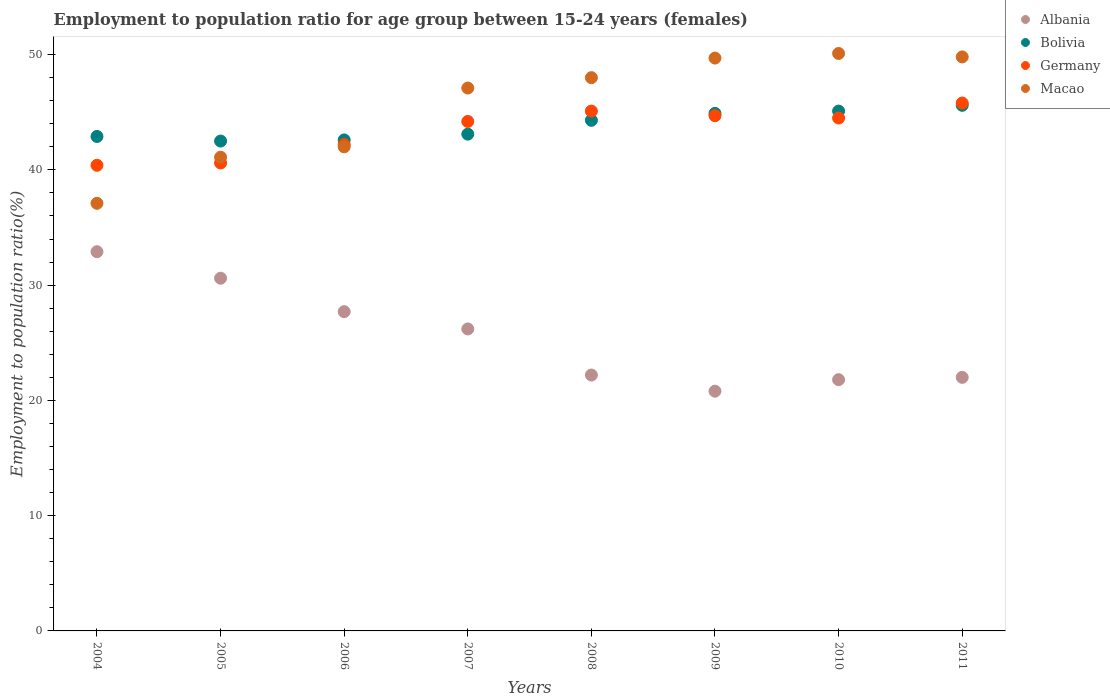How many different coloured dotlines are there?
Your answer should be compact. 4. Is the number of dotlines equal to the number of legend labels?
Provide a succinct answer. Yes. Across all years, what is the maximum employment to population ratio in Bolivia?
Keep it short and to the point. 45.6. Across all years, what is the minimum employment to population ratio in Albania?
Offer a terse response. 20.8. In which year was the employment to population ratio in Albania maximum?
Keep it short and to the point. 2004. In which year was the employment to population ratio in Albania minimum?
Ensure brevity in your answer.  2009. What is the total employment to population ratio in Albania in the graph?
Ensure brevity in your answer.  204.2. What is the difference between the employment to population ratio in Germany in 2004 and that in 2007?
Provide a short and direct response. -3.8. What is the difference between the employment to population ratio in Macao in 2004 and the employment to population ratio in Bolivia in 2009?
Make the answer very short. -7.8. What is the average employment to population ratio in Albania per year?
Provide a short and direct response. 25.53. In the year 2010, what is the difference between the employment to population ratio in Albania and employment to population ratio in Germany?
Ensure brevity in your answer.  -22.7. What is the ratio of the employment to population ratio in Germany in 2005 to that in 2009?
Keep it short and to the point. 0.91. Is the difference between the employment to population ratio in Albania in 2008 and 2010 greater than the difference between the employment to population ratio in Germany in 2008 and 2010?
Provide a short and direct response. No. What is the difference between the highest and the second highest employment to population ratio in Bolivia?
Keep it short and to the point. 0.5. What is the difference between the highest and the lowest employment to population ratio in Bolivia?
Give a very brief answer. 3.1. In how many years, is the employment to population ratio in Macao greater than the average employment to population ratio in Macao taken over all years?
Your response must be concise. 5. Is the sum of the employment to population ratio in Bolivia in 2008 and 2010 greater than the maximum employment to population ratio in Albania across all years?
Give a very brief answer. Yes. Is it the case that in every year, the sum of the employment to population ratio in Macao and employment to population ratio in Albania  is greater than the sum of employment to population ratio in Germany and employment to population ratio in Bolivia?
Ensure brevity in your answer.  No. Does the employment to population ratio in Bolivia monotonically increase over the years?
Give a very brief answer. No. Is the employment to population ratio in Bolivia strictly less than the employment to population ratio in Macao over the years?
Your response must be concise. No. How many dotlines are there?
Your answer should be very brief. 4. Are the values on the major ticks of Y-axis written in scientific E-notation?
Keep it short and to the point. No. Does the graph contain grids?
Ensure brevity in your answer.  No. How many legend labels are there?
Provide a succinct answer. 4. What is the title of the graph?
Keep it short and to the point. Employment to population ratio for age group between 15-24 years (females). Does "Algeria" appear as one of the legend labels in the graph?
Ensure brevity in your answer.  No. What is the label or title of the X-axis?
Give a very brief answer. Years. What is the label or title of the Y-axis?
Offer a terse response. Employment to population ratio(%). What is the Employment to population ratio(%) in Albania in 2004?
Make the answer very short. 32.9. What is the Employment to population ratio(%) in Bolivia in 2004?
Offer a very short reply. 42.9. What is the Employment to population ratio(%) in Germany in 2004?
Keep it short and to the point. 40.4. What is the Employment to population ratio(%) of Macao in 2004?
Offer a very short reply. 37.1. What is the Employment to population ratio(%) in Albania in 2005?
Your response must be concise. 30.6. What is the Employment to population ratio(%) of Bolivia in 2005?
Provide a succinct answer. 42.5. What is the Employment to population ratio(%) in Germany in 2005?
Keep it short and to the point. 40.6. What is the Employment to population ratio(%) in Macao in 2005?
Give a very brief answer. 41.1. What is the Employment to population ratio(%) in Albania in 2006?
Offer a very short reply. 27.7. What is the Employment to population ratio(%) in Bolivia in 2006?
Offer a very short reply. 42.6. What is the Employment to population ratio(%) in Germany in 2006?
Offer a terse response. 42.2. What is the Employment to population ratio(%) in Macao in 2006?
Offer a terse response. 42. What is the Employment to population ratio(%) in Albania in 2007?
Ensure brevity in your answer.  26.2. What is the Employment to population ratio(%) in Bolivia in 2007?
Your answer should be compact. 43.1. What is the Employment to population ratio(%) in Germany in 2007?
Your response must be concise. 44.2. What is the Employment to population ratio(%) of Macao in 2007?
Your answer should be very brief. 47.1. What is the Employment to population ratio(%) of Albania in 2008?
Offer a terse response. 22.2. What is the Employment to population ratio(%) in Bolivia in 2008?
Your answer should be very brief. 44.3. What is the Employment to population ratio(%) of Germany in 2008?
Provide a short and direct response. 45.1. What is the Employment to population ratio(%) in Macao in 2008?
Give a very brief answer. 48. What is the Employment to population ratio(%) in Albania in 2009?
Offer a terse response. 20.8. What is the Employment to population ratio(%) in Bolivia in 2009?
Your answer should be very brief. 44.9. What is the Employment to population ratio(%) in Germany in 2009?
Your response must be concise. 44.7. What is the Employment to population ratio(%) of Macao in 2009?
Provide a succinct answer. 49.7. What is the Employment to population ratio(%) of Albania in 2010?
Your answer should be very brief. 21.8. What is the Employment to population ratio(%) in Bolivia in 2010?
Your response must be concise. 45.1. What is the Employment to population ratio(%) in Germany in 2010?
Provide a short and direct response. 44.5. What is the Employment to population ratio(%) in Macao in 2010?
Give a very brief answer. 50.1. What is the Employment to population ratio(%) in Albania in 2011?
Offer a terse response. 22. What is the Employment to population ratio(%) in Bolivia in 2011?
Offer a terse response. 45.6. What is the Employment to population ratio(%) in Germany in 2011?
Give a very brief answer. 45.8. What is the Employment to population ratio(%) of Macao in 2011?
Your answer should be compact. 49.8. Across all years, what is the maximum Employment to population ratio(%) of Albania?
Make the answer very short. 32.9. Across all years, what is the maximum Employment to population ratio(%) in Bolivia?
Keep it short and to the point. 45.6. Across all years, what is the maximum Employment to population ratio(%) of Germany?
Make the answer very short. 45.8. Across all years, what is the maximum Employment to population ratio(%) in Macao?
Give a very brief answer. 50.1. Across all years, what is the minimum Employment to population ratio(%) in Albania?
Offer a very short reply. 20.8. Across all years, what is the minimum Employment to population ratio(%) in Bolivia?
Offer a terse response. 42.5. Across all years, what is the minimum Employment to population ratio(%) in Germany?
Offer a very short reply. 40.4. Across all years, what is the minimum Employment to population ratio(%) of Macao?
Keep it short and to the point. 37.1. What is the total Employment to population ratio(%) in Albania in the graph?
Provide a succinct answer. 204.2. What is the total Employment to population ratio(%) in Bolivia in the graph?
Your answer should be very brief. 351. What is the total Employment to population ratio(%) in Germany in the graph?
Keep it short and to the point. 347.5. What is the total Employment to population ratio(%) in Macao in the graph?
Your answer should be compact. 364.9. What is the difference between the Employment to population ratio(%) in Macao in 2004 and that in 2005?
Provide a succinct answer. -4. What is the difference between the Employment to population ratio(%) in Albania in 2004 and that in 2006?
Give a very brief answer. 5.2. What is the difference between the Employment to population ratio(%) of Bolivia in 2004 and that in 2006?
Provide a succinct answer. 0.3. What is the difference between the Employment to population ratio(%) in Albania in 2004 and that in 2008?
Offer a terse response. 10.7. What is the difference between the Employment to population ratio(%) in Germany in 2004 and that in 2008?
Make the answer very short. -4.7. What is the difference between the Employment to population ratio(%) of Macao in 2004 and that in 2008?
Your answer should be compact. -10.9. What is the difference between the Employment to population ratio(%) in Albania in 2004 and that in 2010?
Your answer should be compact. 11.1. What is the difference between the Employment to population ratio(%) in Germany in 2004 and that in 2010?
Ensure brevity in your answer.  -4.1. What is the difference between the Employment to population ratio(%) of Macao in 2004 and that in 2010?
Your answer should be very brief. -13. What is the difference between the Employment to population ratio(%) in Albania in 2004 and that in 2011?
Keep it short and to the point. 10.9. What is the difference between the Employment to population ratio(%) in Germany in 2004 and that in 2011?
Offer a very short reply. -5.4. What is the difference between the Employment to population ratio(%) of Macao in 2004 and that in 2011?
Your answer should be very brief. -12.7. What is the difference between the Employment to population ratio(%) in Albania in 2005 and that in 2006?
Your answer should be compact. 2.9. What is the difference between the Employment to population ratio(%) of Bolivia in 2005 and that in 2006?
Your response must be concise. -0.1. What is the difference between the Employment to population ratio(%) in Albania in 2005 and that in 2007?
Offer a very short reply. 4.4. What is the difference between the Employment to population ratio(%) of Germany in 2005 and that in 2007?
Provide a succinct answer. -3.6. What is the difference between the Employment to population ratio(%) of Macao in 2005 and that in 2007?
Offer a terse response. -6. What is the difference between the Employment to population ratio(%) of Albania in 2005 and that in 2008?
Offer a terse response. 8.4. What is the difference between the Employment to population ratio(%) in Macao in 2005 and that in 2008?
Provide a succinct answer. -6.9. What is the difference between the Employment to population ratio(%) in Macao in 2005 and that in 2009?
Give a very brief answer. -8.6. What is the difference between the Employment to population ratio(%) in Albania in 2005 and that in 2010?
Give a very brief answer. 8.8. What is the difference between the Employment to population ratio(%) in Bolivia in 2005 and that in 2010?
Provide a short and direct response. -2.6. What is the difference between the Employment to population ratio(%) of Albania in 2005 and that in 2011?
Offer a terse response. 8.6. What is the difference between the Employment to population ratio(%) of Bolivia in 2005 and that in 2011?
Make the answer very short. -3.1. What is the difference between the Employment to population ratio(%) in Germany in 2005 and that in 2011?
Your answer should be very brief. -5.2. What is the difference between the Employment to population ratio(%) of Macao in 2005 and that in 2011?
Provide a succinct answer. -8.7. What is the difference between the Employment to population ratio(%) in Macao in 2006 and that in 2007?
Your answer should be very brief. -5.1. What is the difference between the Employment to population ratio(%) of Albania in 2006 and that in 2008?
Your answer should be compact. 5.5. What is the difference between the Employment to population ratio(%) of Bolivia in 2006 and that in 2008?
Make the answer very short. -1.7. What is the difference between the Employment to population ratio(%) in Albania in 2006 and that in 2009?
Give a very brief answer. 6.9. What is the difference between the Employment to population ratio(%) of Bolivia in 2006 and that in 2010?
Provide a succinct answer. -2.5. What is the difference between the Employment to population ratio(%) of Germany in 2006 and that in 2010?
Offer a terse response. -2.3. What is the difference between the Employment to population ratio(%) in Albania in 2006 and that in 2011?
Your answer should be compact. 5.7. What is the difference between the Employment to population ratio(%) in Bolivia in 2007 and that in 2008?
Give a very brief answer. -1.2. What is the difference between the Employment to population ratio(%) in Macao in 2007 and that in 2008?
Your answer should be very brief. -0.9. What is the difference between the Employment to population ratio(%) of Bolivia in 2007 and that in 2009?
Ensure brevity in your answer.  -1.8. What is the difference between the Employment to population ratio(%) in Germany in 2007 and that in 2009?
Your response must be concise. -0.5. What is the difference between the Employment to population ratio(%) in Bolivia in 2007 and that in 2010?
Make the answer very short. -2. What is the difference between the Employment to population ratio(%) in Albania in 2007 and that in 2011?
Your answer should be very brief. 4.2. What is the difference between the Employment to population ratio(%) of Bolivia in 2007 and that in 2011?
Provide a succinct answer. -2.5. What is the difference between the Employment to population ratio(%) of Germany in 2007 and that in 2011?
Provide a short and direct response. -1.6. What is the difference between the Employment to population ratio(%) of Macao in 2007 and that in 2011?
Offer a terse response. -2.7. What is the difference between the Employment to population ratio(%) in Bolivia in 2008 and that in 2009?
Provide a succinct answer. -0.6. What is the difference between the Employment to population ratio(%) of Germany in 2008 and that in 2009?
Keep it short and to the point. 0.4. What is the difference between the Employment to population ratio(%) in Albania in 2008 and that in 2010?
Your response must be concise. 0.4. What is the difference between the Employment to population ratio(%) in Bolivia in 2008 and that in 2010?
Ensure brevity in your answer.  -0.8. What is the difference between the Employment to population ratio(%) in Germany in 2008 and that in 2010?
Offer a terse response. 0.6. What is the difference between the Employment to population ratio(%) of Macao in 2008 and that in 2010?
Keep it short and to the point. -2.1. What is the difference between the Employment to population ratio(%) in Bolivia in 2008 and that in 2011?
Offer a terse response. -1.3. What is the difference between the Employment to population ratio(%) of Germany in 2008 and that in 2011?
Keep it short and to the point. -0.7. What is the difference between the Employment to population ratio(%) in Macao in 2008 and that in 2011?
Offer a very short reply. -1.8. What is the difference between the Employment to population ratio(%) in Albania in 2009 and that in 2010?
Your response must be concise. -1. What is the difference between the Employment to population ratio(%) in Germany in 2009 and that in 2011?
Your response must be concise. -1.1. What is the difference between the Employment to population ratio(%) of Macao in 2009 and that in 2011?
Give a very brief answer. -0.1. What is the difference between the Employment to population ratio(%) of Albania in 2010 and that in 2011?
Your answer should be compact. -0.2. What is the difference between the Employment to population ratio(%) of Bolivia in 2010 and that in 2011?
Provide a short and direct response. -0.5. What is the difference between the Employment to population ratio(%) of Germany in 2010 and that in 2011?
Your answer should be very brief. -1.3. What is the difference between the Employment to population ratio(%) in Macao in 2010 and that in 2011?
Ensure brevity in your answer.  0.3. What is the difference between the Employment to population ratio(%) of Albania in 2004 and the Employment to population ratio(%) of Bolivia in 2005?
Give a very brief answer. -9.6. What is the difference between the Employment to population ratio(%) in Bolivia in 2004 and the Employment to population ratio(%) in Germany in 2005?
Offer a very short reply. 2.3. What is the difference between the Employment to population ratio(%) of Germany in 2004 and the Employment to population ratio(%) of Macao in 2005?
Provide a short and direct response. -0.7. What is the difference between the Employment to population ratio(%) in Albania in 2004 and the Employment to population ratio(%) in Germany in 2006?
Your answer should be compact. -9.3. What is the difference between the Employment to population ratio(%) of Germany in 2004 and the Employment to population ratio(%) of Macao in 2006?
Your answer should be compact. -1.6. What is the difference between the Employment to population ratio(%) in Albania in 2004 and the Employment to population ratio(%) in Germany in 2007?
Provide a succinct answer. -11.3. What is the difference between the Employment to population ratio(%) in Albania in 2004 and the Employment to population ratio(%) in Macao in 2007?
Ensure brevity in your answer.  -14.2. What is the difference between the Employment to population ratio(%) of Bolivia in 2004 and the Employment to population ratio(%) of Macao in 2007?
Offer a very short reply. -4.2. What is the difference between the Employment to population ratio(%) of Albania in 2004 and the Employment to population ratio(%) of Bolivia in 2008?
Your answer should be very brief. -11.4. What is the difference between the Employment to population ratio(%) in Albania in 2004 and the Employment to population ratio(%) in Germany in 2008?
Offer a terse response. -12.2. What is the difference between the Employment to population ratio(%) in Albania in 2004 and the Employment to population ratio(%) in Macao in 2008?
Your response must be concise. -15.1. What is the difference between the Employment to population ratio(%) of Bolivia in 2004 and the Employment to population ratio(%) of Macao in 2008?
Make the answer very short. -5.1. What is the difference between the Employment to population ratio(%) in Germany in 2004 and the Employment to population ratio(%) in Macao in 2008?
Give a very brief answer. -7.6. What is the difference between the Employment to population ratio(%) in Albania in 2004 and the Employment to population ratio(%) in Macao in 2009?
Your response must be concise. -16.8. What is the difference between the Employment to population ratio(%) in Albania in 2004 and the Employment to population ratio(%) in Bolivia in 2010?
Your answer should be compact. -12.2. What is the difference between the Employment to population ratio(%) of Albania in 2004 and the Employment to population ratio(%) of Macao in 2010?
Offer a very short reply. -17.2. What is the difference between the Employment to population ratio(%) in Germany in 2004 and the Employment to population ratio(%) in Macao in 2010?
Keep it short and to the point. -9.7. What is the difference between the Employment to population ratio(%) of Albania in 2004 and the Employment to population ratio(%) of Bolivia in 2011?
Give a very brief answer. -12.7. What is the difference between the Employment to population ratio(%) of Albania in 2004 and the Employment to population ratio(%) of Macao in 2011?
Offer a very short reply. -16.9. What is the difference between the Employment to population ratio(%) of Bolivia in 2004 and the Employment to population ratio(%) of Macao in 2011?
Your answer should be compact. -6.9. What is the difference between the Employment to population ratio(%) in Albania in 2005 and the Employment to population ratio(%) in Macao in 2006?
Offer a very short reply. -11.4. What is the difference between the Employment to population ratio(%) in Bolivia in 2005 and the Employment to population ratio(%) in Germany in 2006?
Offer a very short reply. 0.3. What is the difference between the Employment to population ratio(%) of Bolivia in 2005 and the Employment to population ratio(%) of Macao in 2006?
Offer a terse response. 0.5. What is the difference between the Employment to population ratio(%) in Albania in 2005 and the Employment to population ratio(%) in Macao in 2007?
Your answer should be compact. -16.5. What is the difference between the Employment to population ratio(%) of Bolivia in 2005 and the Employment to population ratio(%) of Germany in 2007?
Provide a short and direct response. -1.7. What is the difference between the Employment to population ratio(%) in Bolivia in 2005 and the Employment to population ratio(%) in Macao in 2007?
Provide a succinct answer. -4.6. What is the difference between the Employment to population ratio(%) of Germany in 2005 and the Employment to population ratio(%) of Macao in 2007?
Offer a terse response. -6.5. What is the difference between the Employment to population ratio(%) of Albania in 2005 and the Employment to population ratio(%) of Bolivia in 2008?
Ensure brevity in your answer.  -13.7. What is the difference between the Employment to population ratio(%) of Albania in 2005 and the Employment to population ratio(%) of Macao in 2008?
Keep it short and to the point. -17.4. What is the difference between the Employment to population ratio(%) of Bolivia in 2005 and the Employment to population ratio(%) of Macao in 2008?
Provide a succinct answer. -5.5. What is the difference between the Employment to population ratio(%) in Albania in 2005 and the Employment to population ratio(%) in Bolivia in 2009?
Offer a terse response. -14.3. What is the difference between the Employment to population ratio(%) in Albania in 2005 and the Employment to population ratio(%) in Germany in 2009?
Ensure brevity in your answer.  -14.1. What is the difference between the Employment to population ratio(%) in Albania in 2005 and the Employment to population ratio(%) in Macao in 2009?
Keep it short and to the point. -19.1. What is the difference between the Employment to population ratio(%) of Bolivia in 2005 and the Employment to population ratio(%) of Germany in 2009?
Ensure brevity in your answer.  -2.2. What is the difference between the Employment to population ratio(%) of Bolivia in 2005 and the Employment to population ratio(%) of Macao in 2009?
Provide a succinct answer. -7.2. What is the difference between the Employment to population ratio(%) in Albania in 2005 and the Employment to population ratio(%) in Macao in 2010?
Your response must be concise. -19.5. What is the difference between the Employment to population ratio(%) of Germany in 2005 and the Employment to population ratio(%) of Macao in 2010?
Your answer should be compact. -9.5. What is the difference between the Employment to population ratio(%) in Albania in 2005 and the Employment to population ratio(%) in Bolivia in 2011?
Your answer should be very brief. -15. What is the difference between the Employment to population ratio(%) of Albania in 2005 and the Employment to population ratio(%) of Germany in 2011?
Your response must be concise. -15.2. What is the difference between the Employment to population ratio(%) in Albania in 2005 and the Employment to population ratio(%) in Macao in 2011?
Your answer should be very brief. -19.2. What is the difference between the Employment to population ratio(%) of Bolivia in 2005 and the Employment to population ratio(%) of Macao in 2011?
Provide a succinct answer. -7.3. What is the difference between the Employment to population ratio(%) of Germany in 2005 and the Employment to population ratio(%) of Macao in 2011?
Ensure brevity in your answer.  -9.2. What is the difference between the Employment to population ratio(%) in Albania in 2006 and the Employment to population ratio(%) in Bolivia in 2007?
Ensure brevity in your answer.  -15.4. What is the difference between the Employment to population ratio(%) in Albania in 2006 and the Employment to population ratio(%) in Germany in 2007?
Give a very brief answer. -16.5. What is the difference between the Employment to population ratio(%) of Albania in 2006 and the Employment to population ratio(%) of Macao in 2007?
Provide a succinct answer. -19.4. What is the difference between the Employment to population ratio(%) in Bolivia in 2006 and the Employment to population ratio(%) in Germany in 2007?
Make the answer very short. -1.6. What is the difference between the Employment to population ratio(%) of Bolivia in 2006 and the Employment to population ratio(%) of Macao in 2007?
Your answer should be very brief. -4.5. What is the difference between the Employment to population ratio(%) of Germany in 2006 and the Employment to population ratio(%) of Macao in 2007?
Offer a terse response. -4.9. What is the difference between the Employment to population ratio(%) of Albania in 2006 and the Employment to population ratio(%) of Bolivia in 2008?
Give a very brief answer. -16.6. What is the difference between the Employment to population ratio(%) in Albania in 2006 and the Employment to population ratio(%) in Germany in 2008?
Keep it short and to the point. -17.4. What is the difference between the Employment to population ratio(%) of Albania in 2006 and the Employment to population ratio(%) of Macao in 2008?
Your response must be concise. -20.3. What is the difference between the Employment to population ratio(%) of Bolivia in 2006 and the Employment to population ratio(%) of Germany in 2008?
Your response must be concise. -2.5. What is the difference between the Employment to population ratio(%) in Albania in 2006 and the Employment to population ratio(%) in Bolivia in 2009?
Your response must be concise. -17.2. What is the difference between the Employment to population ratio(%) of Albania in 2006 and the Employment to population ratio(%) of Germany in 2009?
Offer a very short reply. -17. What is the difference between the Employment to population ratio(%) of Bolivia in 2006 and the Employment to population ratio(%) of Macao in 2009?
Your response must be concise. -7.1. What is the difference between the Employment to population ratio(%) of Germany in 2006 and the Employment to population ratio(%) of Macao in 2009?
Offer a terse response. -7.5. What is the difference between the Employment to population ratio(%) in Albania in 2006 and the Employment to population ratio(%) in Bolivia in 2010?
Your answer should be compact. -17.4. What is the difference between the Employment to population ratio(%) in Albania in 2006 and the Employment to population ratio(%) in Germany in 2010?
Give a very brief answer. -16.8. What is the difference between the Employment to population ratio(%) in Albania in 2006 and the Employment to population ratio(%) in Macao in 2010?
Provide a short and direct response. -22.4. What is the difference between the Employment to population ratio(%) in Bolivia in 2006 and the Employment to population ratio(%) in Macao in 2010?
Your response must be concise. -7.5. What is the difference between the Employment to population ratio(%) of Germany in 2006 and the Employment to population ratio(%) of Macao in 2010?
Your answer should be very brief. -7.9. What is the difference between the Employment to population ratio(%) of Albania in 2006 and the Employment to population ratio(%) of Bolivia in 2011?
Keep it short and to the point. -17.9. What is the difference between the Employment to population ratio(%) of Albania in 2006 and the Employment to population ratio(%) of Germany in 2011?
Ensure brevity in your answer.  -18.1. What is the difference between the Employment to population ratio(%) of Albania in 2006 and the Employment to population ratio(%) of Macao in 2011?
Give a very brief answer. -22.1. What is the difference between the Employment to population ratio(%) of Bolivia in 2006 and the Employment to population ratio(%) of Macao in 2011?
Your answer should be very brief. -7.2. What is the difference between the Employment to population ratio(%) of Albania in 2007 and the Employment to population ratio(%) of Bolivia in 2008?
Offer a terse response. -18.1. What is the difference between the Employment to population ratio(%) of Albania in 2007 and the Employment to population ratio(%) of Germany in 2008?
Provide a succinct answer. -18.9. What is the difference between the Employment to population ratio(%) of Albania in 2007 and the Employment to population ratio(%) of Macao in 2008?
Your answer should be compact. -21.8. What is the difference between the Employment to population ratio(%) of Germany in 2007 and the Employment to population ratio(%) of Macao in 2008?
Make the answer very short. -3.8. What is the difference between the Employment to population ratio(%) of Albania in 2007 and the Employment to population ratio(%) of Bolivia in 2009?
Your answer should be very brief. -18.7. What is the difference between the Employment to population ratio(%) in Albania in 2007 and the Employment to population ratio(%) in Germany in 2009?
Offer a very short reply. -18.5. What is the difference between the Employment to population ratio(%) of Albania in 2007 and the Employment to population ratio(%) of Macao in 2009?
Keep it short and to the point. -23.5. What is the difference between the Employment to population ratio(%) in Bolivia in 2007 and the Employment to population ratio(%) in Germany in 2009?
Make the answer very short. -1.6. What is the difference between the Employment to population ratio(%) of Bolivia in 2007 and the Employment to population ratio(%) of Macao in 2009?
Your answer should be compact. -6.6. What is the difference between the Employment to population ratio(%) in Germany in 2007 and the Employment to population ratio(%) in Macao in 2009?
Ensure brevity in your answer.  -5.5. What is the difference between the Employment to population ratio(%) in Albania in 2007 and the Employment to population ratio(%) in Bolivia in 2010?
Provide a short and direct response. -18.9. What is the difference between the Employment to population ratio(%) in Albania in 2007 and the Employment to population ratio(%) in Germany in 2010?
Offer a terse response. -18.3. What is the difference between the Employment to population ratio(%) in Albania in 2007 and the Employment to population ratio(%) in Macao in 2010?
Offer a terse response. -23.9. What is the difference between the Employment to population ratio(%) of Bolivia in 2007 and the Employment to population ratio(%) of Macao in 2010?
Give a very brief answer. -7. What is the difference between the Employment to population ratio(%) in Germany in 2007 and the Employment to population ratio(%) in Macao in 2010?
Your answer should be very brief. -5.9. What is the difference between the Employment to population ratio(%) in Albania in 2007 and the Employment to population ratio(%) in Bolivia in 2011?
Give a very brief answer. -19.4. What is the difference between the Employment to population ratio(%) of Albania in 2007 and the Employment to population ratio(%) of Germany in 2011?
Your answer should be very brief. -19.6. What is the difference between the Employment to population ratio(%) of Albania in 2007 and the Employment to population ratio(%) of Macao in 2011?
Ensure brevity in your answer.  -23.6. What is the difference between the Employment to population ratio(%) in Bolivia in 2007 and the Employment to population ratio(%) in Macao in 2011?
Make the answer very short. -6.7. What is the difference between the Employment to population ratio(%) of Albania in 2008 and the Employment to population ratio(%) of Bolivia in 2009?
Offer a very short reply. -22.7. What is the difference between the Employment to population ratio(%) in Albania in 2008 and the Employment to population ratio(%) in Germany in 2009?
Ensure brevity in your answer.  -22.5. What is the difference between the Employment to population ratio(%) in Albania in 2008 and the Employment to population ratio(%) in Macao in 2009?
Offer a terse response. -27.5. What is the difference between the Employment to population ratio(%) in Bolivia in 2008 and the Employment to population ratio(%) in Germany in 2009?
Offer a terse response. -0.4. What is the difference between the Employment to population ratio(%) in Bolivia in 2008 and the Employment to population ratio(%) in Macao in 2009?
Your answer should be very brief. -5.4. What is the difference between the Employment to population ratio(%) of Germany in 2008 and the Employment to population ratio(%) of Macao in 2009?
Keep it short and to the point. -4.6. What is the difference between the Employment to population ratio(%) of Albania in 2008 and the Employment to population ratio(%) of Bolivia in 2010?
Keep it short and to the point. -22.9. What is the difference between the Employment to population ratio(%) in Albania in 2008 and the Employment to population ratio(%) in Germany in 2010?
Offer a terse response. -22.3. What is the difference between the Employment to population ratio(%) of Albania in 2008 and the Employment to population ratio(%) of Macao in 2010?
Your response must be concise. -27.9. What is the difference between the Employment to population ratio(%) in Bolivia in 2008 and the Employment to population ratio(%) in Germany in 2010?
Provide a succinct answer. -0.2. What is the difference between the Employment to population ratio(%) in Bolivia in 2008 and the Employment to population ratio(%) in Macao in 2010?
Give a very brief answer. -5.8. What is the difference between the Employment to population ratio(%) of Germany in 2008 and the Employment to population ratio(%) of Macao in 2010?
Your response must be concise. -5. What is the difference between the Employment to population ratio(%) of Albania in 2008 and the Employment to population ratio(%) of Bolivia in 2011?
Offer a very short reply. -23.4. What is the difference between the Employment to population ratio(%) in Albania in 2008 and the Employment to population ratio(%) in Germany in 2011?
Your answer should be compact. -23.6. What is the difference between the Employment to population ratio(%) in Albania in 2008 and the Employment to population ratio(%) in Macao in 2011?
Provide a short and direct response. -27.6. What is the difference between the Employment to population ratio(%) of Bolivia in 2008 and the Employment to population ratio(%) of Macao in 2011?
Make the answer very short. -5.5. What is the difference between the Employment to population ratio(%) of Albania in 2009 and the Employment to population ratio(%) of Bolivia in 2010?
Offer a very short reply. -24.3. What is the difference between the Employment to population ratio(%) in Albania in 2009 and the Employment to population ratio(%) in Germany in 2010?
Your answer should be very brief. -23.7. What is the difference between the Employment to population ratio(%) in Albania in 2009 and the Employment to population ratio(%) in Macao in 2010?
Your answer should be very brief. -29.3. What is the difference between the Employment to population ratio(%) in Bolivia in 2009 and the Employment to population ratio(%) in Germany in 2010?
Give a very brief answer. 0.4. What is the difference between the Employment to population ratio(%) in Albania in 2009 and the Employment to population ratio(%) in Bolivia in 2011?
Your answer should be compact. -24.8. What is the difference between the Employment to population ratio(%) of Albania in 2009 and the Employment to population ratio(%) of Germany in 2011?
Make the answer very short. -25. What is the difference between the Employment to population ratio(%) of Bolivia in 2009 and the Employment to population ratio(%) of Germany in 2011?
Your answer should be very brief. -0.9. What is the difference between the Employment to population ratio(%) in Bolivia in 2009 and the Employment to population ratio(%) in Macao in 2011?
Your answer should be compact. -4.9. What is the difference between the Employment to population ratio(%) of Albania in 2010 and the Employment to population ratio(%) of Bolivia in 2011?
Your response must be concise. -23.8. What is the difference between the Employment to population ratio(%) of Bolivia in 2010 and the Employment to population ratio(%) of Macao in 2011?
Your answer should be very brief. -4.7. What is the difference between the Employment to population ratio(%) of Germany in 2010 and the Employment to population ratio(%) of Macao in 2011?
Give a very brief answer. -5.3. What is the average Employment to population ratio(%) in Albania per year?
Keep it short and to the point. 25.52. What is the average Employment to population ratio(%) of Bolivia per year?
Give a very brief answer. 43.88. What is the average Employment to population ratio(%) in Germany per year?
Provide a short and direct response. 43.44. What is the average Employment to population ratio(%) in Macao per year?
Offer a very short reply. 45.61. In the year 2004, what is the difference between the Employment to population ratio(%) in Albania and Employment to population ratio(%) in Bolivia?
Your answer should be compact. -10. In the year 2004, what is the difference between the Employment to population ratio(%) in Albania and Employment to population ratio(%) in Germany?
Offer a terse response. -7.5. In the year 2004, what is the difference between the Employment to population ratio(%) in Albania and Employment to population ratio(%) in Macao?
Provide a short and direct response. -4.2. In the year 2004, what is the difference between the Employment to population ratio(%) of Bolivia and Employment to population ratio(%) of Germany?
Your answer should be compact. 2.5. In the year 2005, what is the difference between the Employment to population ratio(%) of Albania and Employment to population ratio(%) of Bolivia?
Give a very brief answer. -11.9. In the year 2005, what is the difference between the Employment to population ratio(%) of Albania and Employment to population ratio(%) of Germany?
Offer a very short reply. -10. In the year 2005, what is the difference between the Employment to population ratio(%) in Germany and Employment to population ratio(%) in Macao?
Keep it short and to the point. -0.5. In the year 2006, what is the difference between the Employment to population ratio(%) of Albania and Employment to population ratio(%) of Bolivia?
Make the answer very short. -14.9. In the year 2006, what is the difference between the Employment to population ratio(%) in Albania and Employment to population ratio(%) in Macao?
Your answer should be very brief. -14.3. In the year 2007, what is the difference between the Employment to population ratio(%) in Albania and Employment to population ratio(%) in Bolivia?
Your answer should be very brief. -16.9. In the year 2007, what is the difference between the Employment to population ratio(%) in Albania and Employment to population ratio(%) in Macao?
Your answer should be very brief. -20.9. In the year 2007, what is the difference between the Employment to population ratio(%) in Bolivia and Employment to population ratio(%) in Germany?
Offer a very short reply. -1.1. In the year 2007, what is the difference between the Employment to population ratio(%) in Germany and Employment to population ratio(%) in Macao?
Keep it short and to the point. -2.9. In the year 2008, what is the difference between the Employment to population ratio(%) in Albania and Employment to population ratio(%) in Bolivia?
Offer a very short reply. -22.1. In the year 2008, what is the difference between the Employment to population ratio(%) in Albania and Employment to population ratio(%) in Germany?
Offer a terse response. -22.9. In the year 2008, what is the difference between the Employment to population ratio(%) of Albania and Employment to population ratio(%) of Macao?
Give a very brief answer. -25.8. In the year 2008, what is the difference between the Employment to population ratio(%) in Bolivia and Employment to population ratio(%) in Macao?
Provide a succinct answer. -3.7. In the year 2008, what is the difference between the Employment to population ratio(%) in Germany and Employment to population ratio(%) in Macao?
Provide a succinct answer. -2.9. In the year 2009, what is the difference between the Employment to population ratio(%) in Albania and Employment to population ratio(%) in Bolivia?
Your response must be concise. -24.1. In the year 2009, what is the difference between the Employment to population ratio(%) in Albania and Employment to population ratio(%) in Germany?
Offer a terse response. -23.9. In the year 2009, what is the difference between the Employment to population ratio(%) in Albania and Employment to population ratio(%) in Macao?
Provide a short and direct response. -28.9. In the year 2010, what is the difference between the Employment to population ratio(%) in Albania and Employment to population ratio(%) in Bolivia?
Offer a very short reply. -23.3. In the year 2010, what is the difference between the Employment to population ratio(%) of Albania and Employment to population ratio(%) of Germany?
Keep it short and to the point. -22.7. In the year 2010, what is the difference between the Employment to population ratio(%) of Albania and Employment to population ratio(%) of Macao?
Keep it short and to the point. -28.3. In the year 2010, what is the difference between the Employment to population ratio(%) of Bolivia and Employment to population ratio(%) of Germany?
Your answer should be very brief. 0.6. In the year 2010, what is the difference between the Employment to population ratio(%) in Germany and Employment to population ratio(%) in Macao?
Your answer should be very brief. -5.6. In the year 2011, what is the difference between the Employment to population ratio(%) of Albania and Employment to population ratio(%) of Bolivia?
Keep it short and to the point. -23.6. In the year 2011, what is the difference between the Employment to population ratio(%) in Albania and Employment to population ratio(%) in Germany?
Offer a terse response. -23.8. In the year 2011, what is the difference between the Employment to population ratio(%) of Albania and Employment to population ratio(%) of Macao?
Make the answer very short. -27.8. In the year 2011, what is the difference between the Employment to population ratio(%) in Bolivia and Employment to population ratio(%) in Germany?
Provide a succinct answer. -0.2. In the year 2011, what is the difference between the Employment to population ratio(%) of Bolivia and Employment to population ratio(%) of Macao?
Your response must be concise. -4.2. What is the ratio of the Employment to population ratio(%) of Albania in 2004 to that in 2005?
Your answer should be very brief. 1.08. What is the ratio of the Employment to population ratio(%) in Bolivia in 2004 to that in 2005?
Offer a very short reply. 1.01. What is the ratio of the Employment to population ratio(%) of Germany in 2004 to that in 2005?
Your answer should be compact. 1. What is the ratio of the Employment to population ratio(%) of Macao in 2004 to that in 2005?
Offer a terse response. 0.9. What is the ratio of the Employment to population ratio(%) of Albania in 2004 to that in 2006?
Give a very brief answer. 1.19. What is the ratio of the Employment to population ratio(%) of Germany in 2004 to that in 2006?
Your answer should be very brief. 0.96. What is the ratio of the Employment to population ratio(%) in Macao in 2004 to that in 2006?
Make the answer very short. 0.88. What is the ratio of the Employment to population ratio(%) of Albania in 2004 to that in 2007?
Offer a very short reply. 1.26. What is the ratio of the Employment to population ratio(%) in Bolivia in 2004 to that in 2007?
Your answer should be compact. 1. What is the ratio of the Employment to population ratio(%) of Germany in 2004 to that in 2007?
Make the answer very short. 0.91. What is the ratio of the Employment to population ratio(%) in Macao in 2004 to that in 2007?
Ensure brevity in your answer.  0.79. What is the ratio of the Employment to population ratio(%) in Albania in 2004 to that in 2008?
Provide a succinct answer. 1.48. What is the ratio of the Employment to population ratio(%) of Bolivia in 2004 to that in 2008?
Your answer should be very brief. 0.97. What is the ratio of the Employment to population ratio(%) in Germany in 2004 to that in 2008?
Your answer should be compact. 0.9. What is the ratio of the Employment to population ratio(%) in Macao in 2004 to that in 2008?
Provide a short and direct response. 0.77. What is the ratio of the Employment to population ratio(%) of Albania in 2004 to that in 2009?
Your response must be concise. 1.58. What is the ratio of the Employment to population ratio(%) of Bolivia in 2004 to that in 2009?
Your answer should be compact. 0.96. What is the ratio of the Employment to population ratio(%) in Germany in 2004 to that in 2009?
Offer a very short reply. 0.9. What is the ratio of the Employment to population ratio(%) of Macao in 2004 to that in 2009?
Give a very brief answer. 0.75. What is the ratio of the Employment to population ratio(%) in Albania in 2004 to that in 2010?
Provide a succinct answer. 1.51. What is the ratio of the Employment to population ratio(%) in Bolivia in 2004 to that in 2010?
Make the answer very short. 0.95. What is the ratio of the Employment to population ratio(%) in Germany in 2004 to that in 2010?
Your answer should be very brief. 0.91. What is the ratio of the Employment to population ratio(%) of Macao in 2004 to that in 2010?
Offer a terse response. 0.74. What is the ratio of the Employment to population ratio(%) of Albania in 2004 to that in 2011?
Offer a terse response. 1.5. What is the ratio of the Employment to population ratio(%) in Bolivia in 2004 to that in 2011?
Keep it short and to the point. 0.94. What is the ratio of the Employment to population ratio(%) in Germany in 2004 to that in 2011?
Offer a terse response. 0.88. What is the ratio of the Employment to population ratio(%) of Macao in 2004 to that in 2011?
Offer a very short reply. 0.74. What is the ratio of the Employment to population ratio(%) in Albania in 2005 to that in 2006?
Offer a terse response. 1.1. What is the ratio of the Employment to population ratio(%) of Germany in 2005 to that in 2006?
Your answer should be compact. 0.96. What is the ratio of the Employment to population ratio(%) of Macao in 2005 to that in 2006?
Give a very brief answer. 0.98. What is the ratio of the Employment to population ratio(%) of Albania in 2005 to that in 2007?
Make the answer very short. 1.17. What is the ratio of the Employment to population ratio(%) of Bolivia in 2005 to that in 2007?
Make the answer very short. 0.99. What is the ratio of the Employment to population ratio(%) of Germany in 2005 to that in 2007?
Make the answer very short. 0.92. What is the ratio of the Employment to population ratio(%) of Macao in 2005 to that in 2007?
Make the answer very short. 0.87. What is the ratio of the Employment to population ratio(%) in Albania in 2005 to that in 2008?
Provide a succinct answer. 1.38. What is the ratio of the Employment to population ratio(%) in Bolivia in 2005 to that in 2008?
Keep it short and to the point. 0.96. What is the ratio of the Employment to population ratio(%) in Germany in 2005 to that in 2008?
Provide a short and direct response. 0.9. What is the ratio of the Employment to population ratio(%) in Macao in 2005 to that in 2008?
Provide a short and direct response. 0.86. What is the ratio of the Employment to population ratio(%) in Albania in 2005 to that in 2009?
Make the answer very short. 1.47. What is the ratio of the Employment to population ratio(%) of Bolivia in 2005 to that in 2009?
Make the answer very short. 0.95. What is the ratio of the Employment to population ratio(%) of Germany in 2005 to that in 2009?
Offer a very short reply. 0.91. What is the ratio of the Employment to population ratio(%) in Macao in 2005 to that in 2009?
Your answer should be very brief. 0.83. What is the ratio of the Employment to population ratio(%) of Albania in 2005 to that in 2010?
Make the answer very short. 1.4. What is the ratio of the Employment to population ratio(%) of Bolivia in 2005 to that in 2010?
Your answer should be compact. 0.94. What is the ratio of the Employment to population ratio(%) of Germany in 2005 to that in 2010?
Keep it short and to the point. 0.91. What is the ratio of the Employment to population ratio(%) of Macao in 2005 to that in 2010?
Keep it short and to the point. 0.82. What is the ratio of the Employment to population ratio(%) of Albania in 2005 to that in 2011?
Give a very brief answer. 1.39. What is the ratio of the Employment to population ratio(%) of Bolivia in 2005 to that in 2011?
Your answer should be very brief. 0.93. What is the ratio of the Employment to population ratio(%) of Germany in 2005 to that in 2011?
Provide a succinct answer. 0.89. What is the ratio of the Employment to population ratio(%) in Macao in 2005 to that in 2011?
Your response must be concise. 0.83. What is the ratio of the Employment to population ratio(%) of Albania in 2006 to that in 2007?
Offer a terse response. 1.06. What is the ratio of the Employment to population ratio(%) of Bolivia in 2006 to that in 2007?
Offer a terse response. 0.99. What is the ratio of the Employment to population ratio(%) of Germany in 2006 to that in 2007?
Provide a short and direct response. 0.95. What is the ratio of the Employment to population ratio(%) of Macao in 2006 to that in 2007?
Keep it short and to the point. 0.89. What is the ratio of the Employment to population ratio(%) in Albania in 2006 to that in 2008?
Offer a very short reply. 1.25. What is the ratio of the Employment to population ratio(%) in Bolivia in 2006 to that in 2008?
Provide a short and direct response. 0.96. What is the ratio of the Employment to population ratio(%) in Germany in 2006 to that in 2008?
Offer a very short reply. 0.94. What is the ratio of the Employment to population ratio(%) in Macao in 2006 to that in 2008?
Provide a succinct answer. 0.88. What is the ratio of the Employment to population ratio(%) in Albania in 2006 to that in 2009?
Your answer should be compact. 1.33. What is the ratio of the Employment to population ratio(%) of Bolivia in 2006 to that in 2009?
Provide a short and direct response. 0.95. What is the ratio of the Employment to population ratio(%) in Germany in 2006 to that in 2009?
Offer a terse response. 0.94. What is the ratio of the Employment to population ratio(%) in Macao in 2006 to that in 2009?
Your answer should be very brief. 0.85. What is the ratio of the Employment to population ratio(%) in Albania in 2006 to that in 2010?
Provide a short and direct response. 1.27. What is the ratio of the Employment to population ratio(%) of Bolivia in 2006 to that in 2010?
Your answer should be very brief. 0.94. What is the ratio of the Employment to population ratio(%) in Germany in 2006 to that in 2010?
Provide a succinct answer. 0.95. What is the ratio of the Employment to population ratio(%) of Macao in 2006 to that in 2010?
Provide a short and direct response. 0.84. What is the ratio of the Employment to population ratio(%) of Albania in 2006 to that in 2011?
Your response must be concise. 1.26. What is the ratio of the Employment to population ratio(%) of Bolivia in 2006 to that in 2011?
Your answer should be very brief. 0.93. What is the ratio of the Employment to population ratio(%) in Germany in 2006 to that in 2011?
Your answer should be very brief. 0.92. What is the ratio of the Employment to population ratio(%) of Macao in 2006 to that in 2011?
Your answer should be very brief. 0.84. What is the ratio of the Employment to population ratio(%) in Albania in 2007 to that in 2008?
Your response must be concise. 1.18. What is the ratio of the Employment to population ratio(%) in Bolivia in 2007 to that in 2008?
Offer a terse response. 0.97. What is the ratio of the Employment to population ratio(%) in Germany in 2007 to that in 2008?
Your answer should be very brief. 0.98. What is the ratio of the Employment to population ratio(%) in Macao in 2007 to that in 2008?
Ensure brevity in your answer.  0.98. What is the ratio of the Employment to population ratio(%) of Albania in 2007 to that in 2009?
Give a very brief answer. 1.26. What is the ratio of the Employment to population ratio(%) in Bolivia in 2007 to that in 2009?
Give a very brief answer. 0.96. What is the ratio of the Employment to population ratio(%) of Germany in 2007 to that in 2009?
Give a very brief answer. 0.99. What is the ratio of the Employment to population ratio(%) in Macao in 2007 to that in 2009?
Provide a short and direct response. 0.95. What is the ratio of the Employment to population ratio(%) of Albania in 2007 to that in 2010?
Provide a succinct answer. 1.2. What is the ratio of the Employment to population ratio(%) of Bolivia in 2007 to that in 2010?
Your response must be concise. 0.96. What is the ratio of the Employment to population ratio(%) in Germany in 2007 to that in 2010?
Your answer should be compact. 0.99. What is the ratio of the Employment to population ratio(%) in Macao in 2007 to that in 2010?
Your answer should be compact. 0.94. What is the ratio of the Employment to population ratio(%) in Albania in 2007 to that in 2011?
Your answer should be compact. 1.19. What is the ratio of the Employment to population ratio(%) of Bolivia in 2007 to that in 2011?
Provide a short and direct response. 0.95. What is the ratio of the Employment to population ratio(%) of Germany in 2007 to that in 2011?
Provide a short and direct response. 0.97. What is the ratio of the Employment to population ratio(%) in Macao in 2007 to that in 2011?
Offer a very short reply. 0.95. What is the ratio of the Employment to population ratio(%) of Albania in 2008 to that in 2009?
Provide a succinct answer. 1.07. What is the ratio of the Employment to population ratio(%) of Bolivia in 2008 to that in 2009?
Provide a succinct answer. 0.99. What is the ratio of the Employment to population ratio(%) in Germany in 2008 to that in 2009?
Provide a short and direct response. 1.01. What is the ratio of the Employment to population ratio(%) in Macao in 2008 to that in 2009?
Offer a terse response. 0.97. What is the ratio of the Employment to population ratio(%) of Albania in 2008 to that in 2010?
Give a very brief answer. 1.02. What is the ratio of the Employment to population ratio(%) in Bolivia in 2008 to that in 2010?
Your answer should be very brief. 0.98. What is the ratio of the Employment to population ratio(%) in Germany in 2008 to that in 2010?
Ensure brevity in your answer.  1.01. What is the ratio of the Employment to population ratio(%) in Macao in 2008 to that in 2010?
Your response must be concise. 0.96. What is the ratio of the Employment to population ratio(%) of Albania in 2008 to that in 2011?
Give a very brief answer. 1.01. What is the ratio of the Employment to population ratio(%) of Bolivia in 2008 to that in 2011?
Your response must be concise. 0.97. What is the ratio of the Employment to population ratio(%) of Germany in 2008 to that in 2011?
Offer a very short reply. 0.98. What is the ratio of the Employment to population ratio(%) of Macao in 2008 to that in 2011?
Keep it short and to the point. 0.96. What is the ratio of the Employment to population ratio(%) in Albania in 2009 to that in 2010?
Your response must be concise. 0.95. What is the ratio of the Employment to population ratio(%) in Bolivia in 2009 to that in 2010?
Provide a succinct answer. 1. What is the ratio of the Employment to population ratio(%) of Germany in 2009 to that in 2010?
Your response must be concise. 1. What is the ratio of the Employment to population ratio(%) in Albania in 2009 to that in 2011?
Give a very brief answer. 0.95. What is the ratio of the Employment to population ratio(%) in Bolivia in 2009 to that in 2011?
Make the answer very short. 0.98. What is the ratio of the Employment to population ratio(%) of Albania in 2010 to that in 2011?
Provide a succinct answer. 0.99. What is the ratio of the Employment to population ratio(%) of Bolivia in 2010 to that in 2011?
Ensure brevity in your answer.  0.99. What is the ratio of the Employment to population ratio(%) in Germany in 2010 to that in 2011?
Ensure brevity in your answer.  0.97. What is the difference between the highest and the second highest Employment to population ratio(%) of Albania?
Your response must be concise. 2.3. What is the difference between the highest and the second highest Employment to population ratio(%) of Bolivia?
Ensure brevity in your answer.  0.5. What is the difference between the highest and the second highest Employment to population ratio(%) of Germany?
Make the answer very short. 0.7. What is the difference between the highest and the second highest Employment to population ratio(%) of Macao?
Offer a terse response. 0.3. What is the difference between the highest and the lowest Employment to population ratio(%) of Germany?
Give a very brief answer. 5.4. 